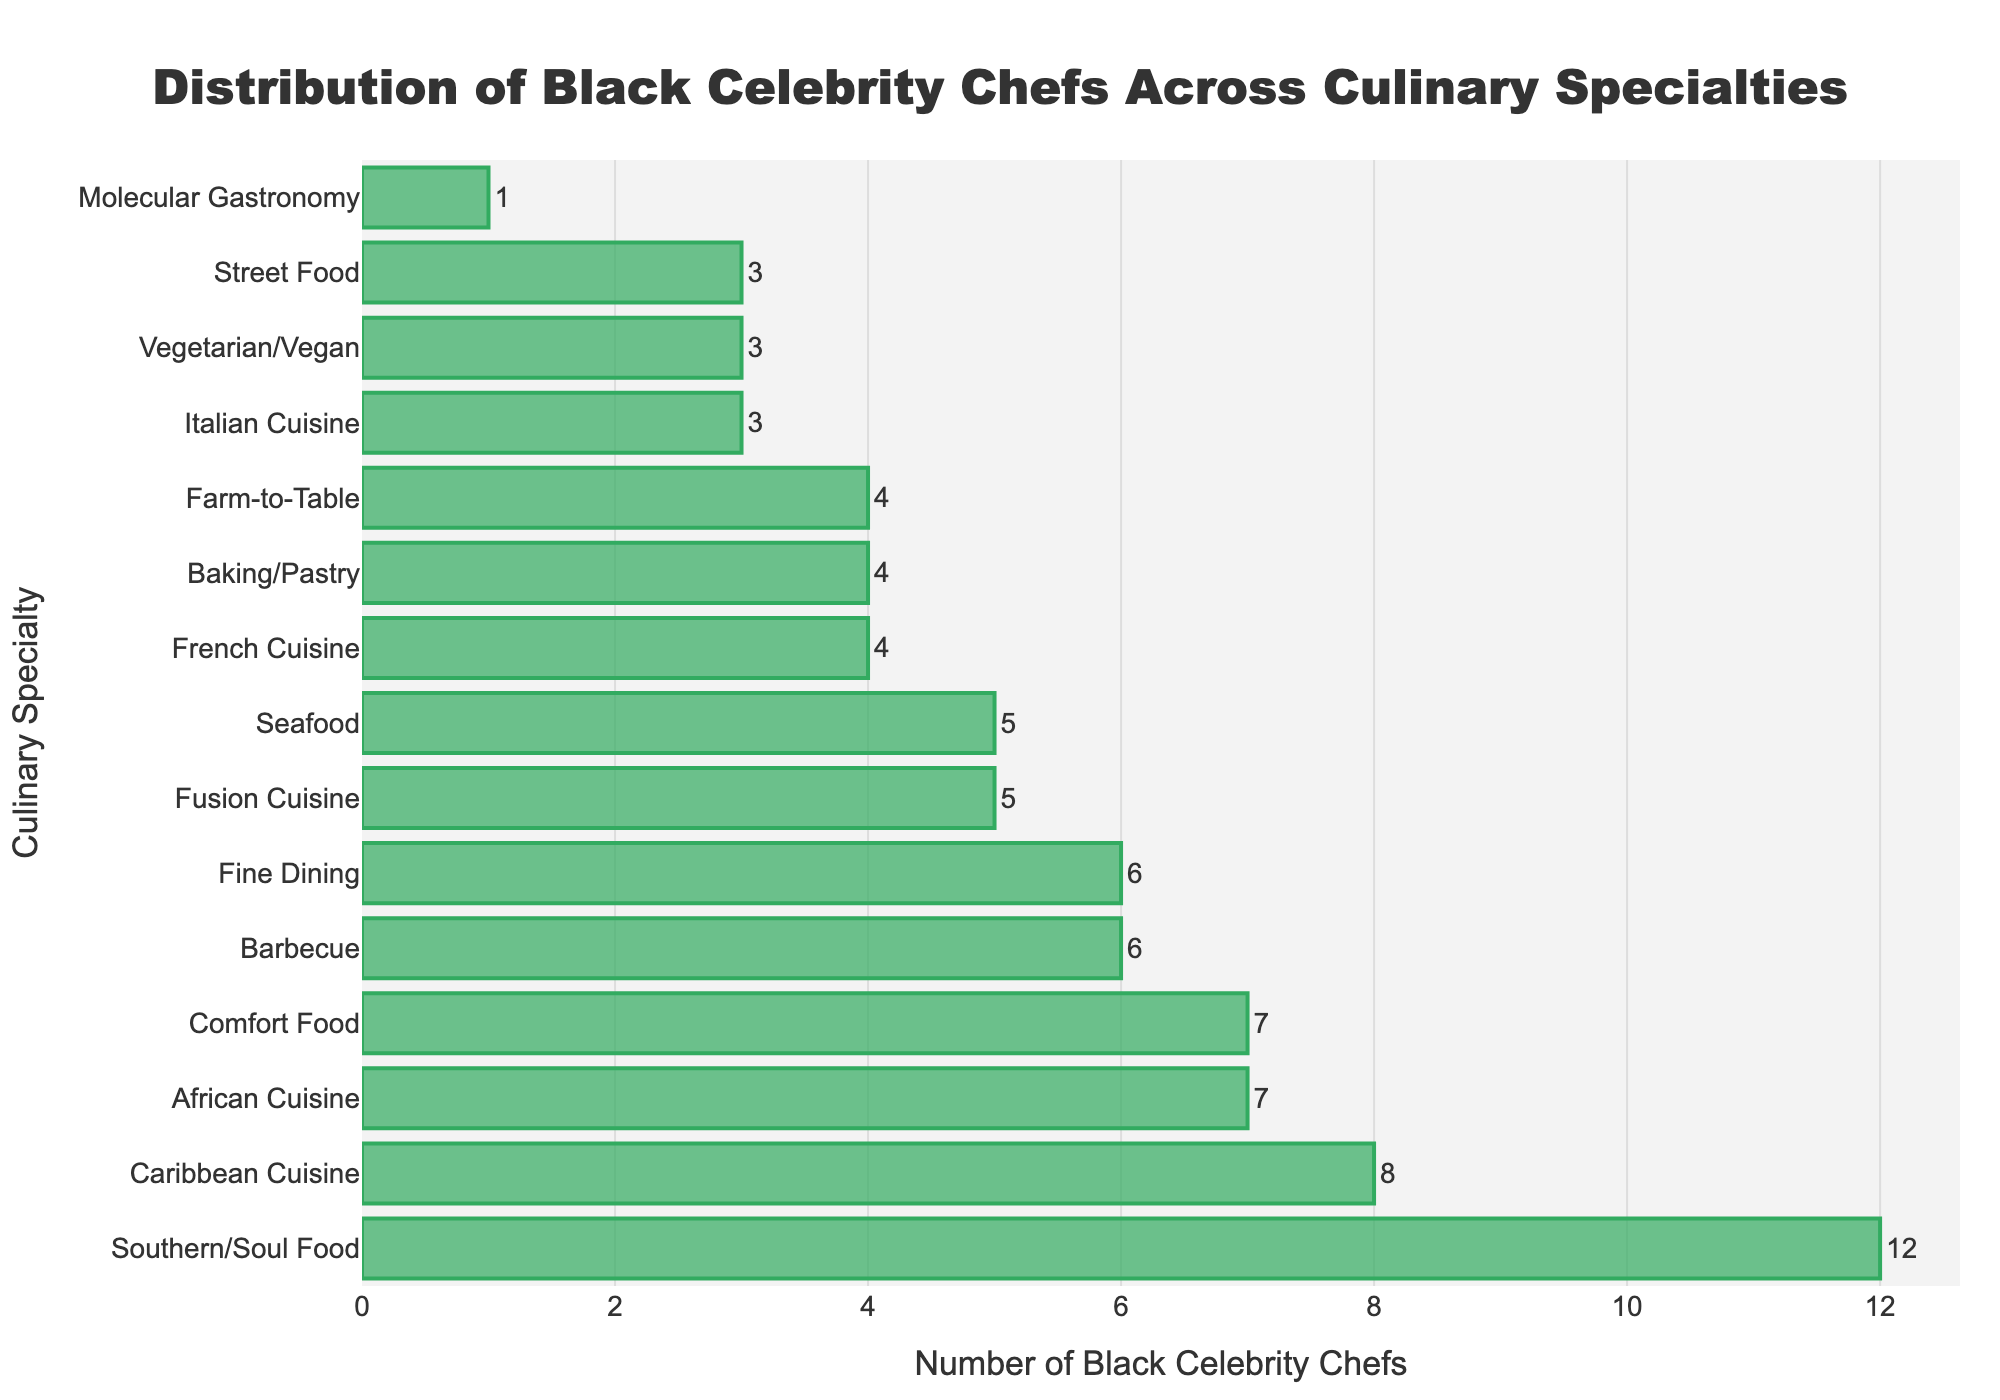Which culinary specialty has the highest number of Black celebrity chefs? The specialty with the highest bar represents the highest number of chefs. Here, the bar for Southern/Soul Food is the longest indicating this specialty has the highest number of chefs.
Answer: Southern/Soul Food What is the total number of Black celebrity chefs for French Cuisine and Italian Cuisine combined? Add the number of Black celebrity chefs in French Cuisine (4) and Italian Cuisine (3). Hence, 4 + 3 = 7.
Answer: 7 Which culinary specialty has more Black celebrity chefs, Barbecue or Farm-to-Table? Compare the lengths of the bars for Barbecue and Farm-to-Table. The Barbecue bar is longer, indicating it has more chefs.
Answer: Barbecue How many more Black celebrity chefs specialize in Southern/Soul Food compared to Molecular Gastronomy? Subtract the number of chefs in Molecular Gastronomy (1) from those in Southern/Soul Food (12). 12 - 1 = 11.
Answer: 11 What is the average number of Black celebrity chefs across Caribbean Cuisine, African Cuisine, and Street Food? Sum the number of chefs in Caribbean Cuisine (8), African Cuisine (7), and Street Food (3), which is 18. Then divide by 3. 18 / 3 = 6.
Answer: 6 Is the number of Black celebrity chefs in Baking/Pastry equal to the number in Farm-to-Table? Compare the bars for Baking/Pastry and Farm-to-Table. Both have bars of equal length, indicating each has 4 chefs.
Answer: Yes Which culinary specialty has the smallest number of Black celebrity chefs? Identify the shortest bar. The bar for Molecular Gastronomy is the shortest, indicating it has the smallest number of chefs.
Answer: Molecular Gastronomy How many more Black celebrity chefs are there in Southern/Soul Food compared to Fine Dining? Subtract the number of chefs in Fine Dining (6) from those in Southern/Soul Food (12). 12 - 6 = 6.
Answer: 6 Which culinary specialties have exactly 3 Black celebrity chefs each? Identify the bars that align with the value 3 on the x-axis. Both Italian Cuisine and Street Food bars align with 3.
Answer: Italian Cuisine, Street Food What is the sum of Black celebrity chefs in Seafood, Fusion Cuisine, and Barbecue? Sum the number of chefs in Seafood (5), Fusion Cuisine (5), and Barbecue (6). The total is 5 + 5 + 6 = 16.
Answer: 16 